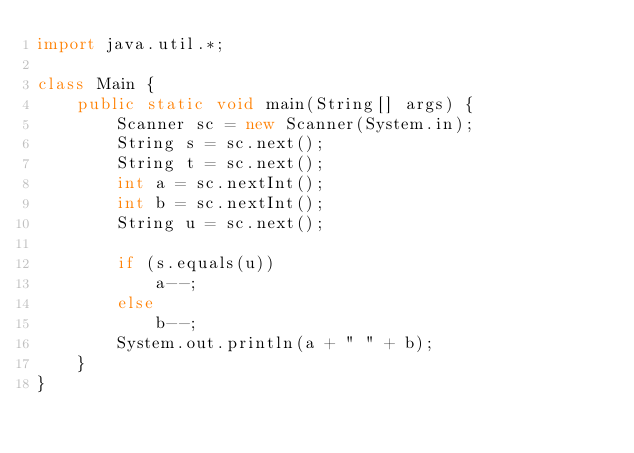Convert code to text. <code><loc_0><loc_0><loc_500><loc_500><_Java_>import java.util.*;

class Main {
    public static void main(String[] args) {
        Scanner sc = new Scanner(System.in);
        String s = sc.next();
        String t = sc.next();
        int a = sc.nextInt();
        int b = sc.nextInt();
        String u = sc.next();

        if (s.equals(u))
            a--;
        else
            b--;
        System.out.println(a + " " + b);
    }
}</code> 